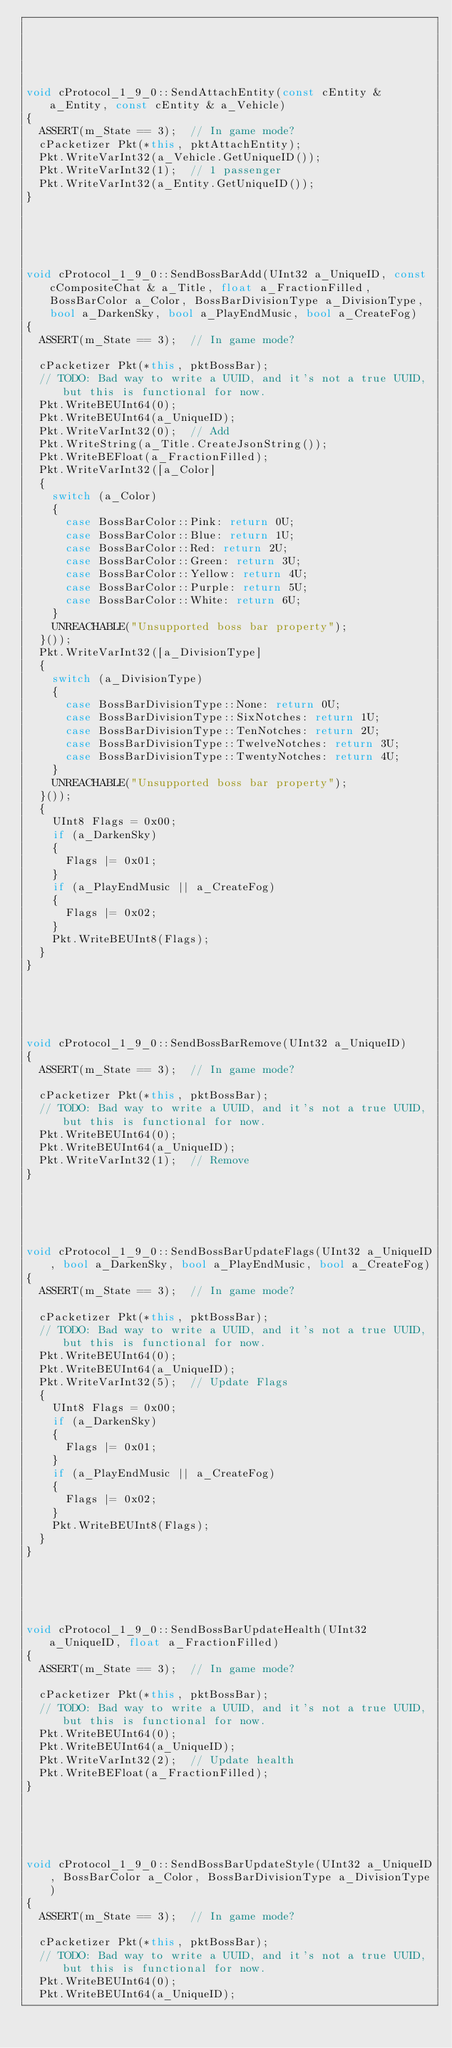Convert code to text. <code><loc_0><loc_0><loc_500><loc_500><_C++_>




void cProtocol_1_9_0::SendAttachEntity(const cEntity & a_Entity, const cEntity & a_Vehicle)
{
	ASSERT(m_State == 3);  // In game mode?
	cPacketizer Pkt(*this, pktAttachEntity);
	Pkt.WriteVarInt32(a_Vehicle.GetUniqueID());
	Pkt.WriteVarInt32(1);  // 1 passenger
	Pkt.WriteVarInt32(a_Entity.GetUniqueID());
}





void cProtocol_1_9_0::SendBossBarAdd(UInt32 a_UniqueID, const cCompositeChat & a_Title, float a_FractionFilled, BossBarColor a_Color, BossBarDivisionType a_DivisionType, bool a_DarkenSky, bool a_PlayEndMusic, bool a_CreateFog)
{
	ASSERT(m_State == 3);  // In game mode?

	cPacketizer Pkt(*this, pktBossBar);
	// TODO: Bad way to write a UUID, and it's not a true UUID, but this is functional for now.
	Pkt.WriteBEUInt64(0);
	Pkt.WriteBEUInt64(a_UniqueID);
	Pkt.WriteVarInt32(0);  // Add
	Pkt.WriteString(a_Title.CreateJsonString());
	Pkt.WriteBEFloat(a_FractionFilled);
	Pkt.WriteVarInt32([a_Color]
	{
		switch (a_Color)
		{
			case BossBarColor::Pink: return 0U;
			case BossBarColor::Blue: return 1U;
			case BossBarColor::Red: return 2U;
			case BossBarColor::Green: return 3U;
			case BossBarColor::Yellow: return 4U;
			case BossBarColor::Purple: return 5U;
			case BossBarColor::White: return 6U;
		}
		UNREACHABLE("Unsupported boss bar property");
	}());
	Pkt.WriteVarInt32([a_DivisionType]
	{
		switch (a_DivisionType)
		{
			case BossBarDivisionType::None: return 0U;
			case BossBarDivisionType::SixNotches: return 1U;
			case BossBarDivisionType::TenNotches: return 2U;
			case BossBarDivisionType::TwelveNotches: return 3U;
			case BossBarDivisionType::TwentyNotches: return 4U;
		}
		UNREACHABLE("Unsupported boss bar property");
	}());
	{
		UInt8 Flags = 0x00;
		if (a_DarkenSky)
		{
			Flags |= 0x01;
		}
		if (a_PlayEndMusic || a_CreateFog)
		{
			Flags |= 0x02;
		}
		Pkt.WriteBEUInt8(Flags);
	}
}





void cProtocol_1_9_0::SendBossBarRemove(UInt32 a_UniqueID)
{
	ASSERT(m_State == 3);  // In game mode?

	cPacketizer Pkt(*this, pktBossBar);
	// TODO: Bad way to write a UUID, and it's not a true UUID, but this is functional for now.
	Pkt.WriteBEUInt64(0);
	Pkt.WriteBEUInt64(a_UniqueID);
	Pkt.WriteVarInt32(1);  // Remove
}





void cProtocol_1_9_0::SendBossBarUpdateFlags(UInt32 a_UniqueID, bool a_DarkenSky, bool a_PlayEndMusic, bool a_CreateFog)
{
	ASSERT(m_State == 3);  // In game mode?

	cPacketizer Pkt(*this, pktBossBar);
	// TODO: Bad way to write a UUID, and it's not a true UUID, but this is functional for now.
	Pkt.WriteBEUInt64(0);
	Pkt.WriteBEUInt64(a_UniqueID);
	Pkt.WriteVarInt32(5);  // Update Flags
	{
		UInt8 Flags = 0x00;
		if (a_DarkenSky)
		{
			Flags |= 0x01;
		}
		if (a_PlayEndMusic || a_CreateFog)
		{
			Flags |= 0x02;
		}
		Pkt.WriteBEUInt8(Flags);
	}
}





void cProtocol_1_9_0::SendBossBarUpdateHealth(UInt32 a_UniqueID, float a_FractionFilled)
{
	ASSERT(m_State == 3);  // In game mode?

	cPacketizer Pkt(*this, pktBossBar);
	// TODO: Bad way to write a UUID, and it's not a true UUID, but this is functional for now.
	Pkt.WriteBEUInt64(0);
	Pkt.WriteBEUInt64(a_UniqueID);
	Pkt.WriteVarInt32(2);  // Update health
	Pkt.WriteBEFloat(a_FractionFilled);
}





void cProtocol_1_9_0::SendBossBarUpdateStyle(UInt32 a_UniqueID, BossBarColor a_Color, BossBarDivisionType a_DivisionType)
{
	ASSERT(m_State == 3);  // In game mode?

	cPacketizer Pkt(*this, pktBossBar);
	// TODO: Bad way to write a UUID, and it's not a true UUID, but this is functional for now.
	Pkt.WriteBEUInt64(0);
	Pkt.WriteBEUInt64(a_UniqueID);</code> 